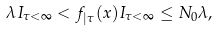Convert formula to latex. <formula><loc_0><loc_0><loc_500><loc_500>\lambda I _ { \tau < \infty } < f _ { | \tau } ( x ) I _ { \tau < \infty } \leq N _ { 0 } \lambda ,</formula> 